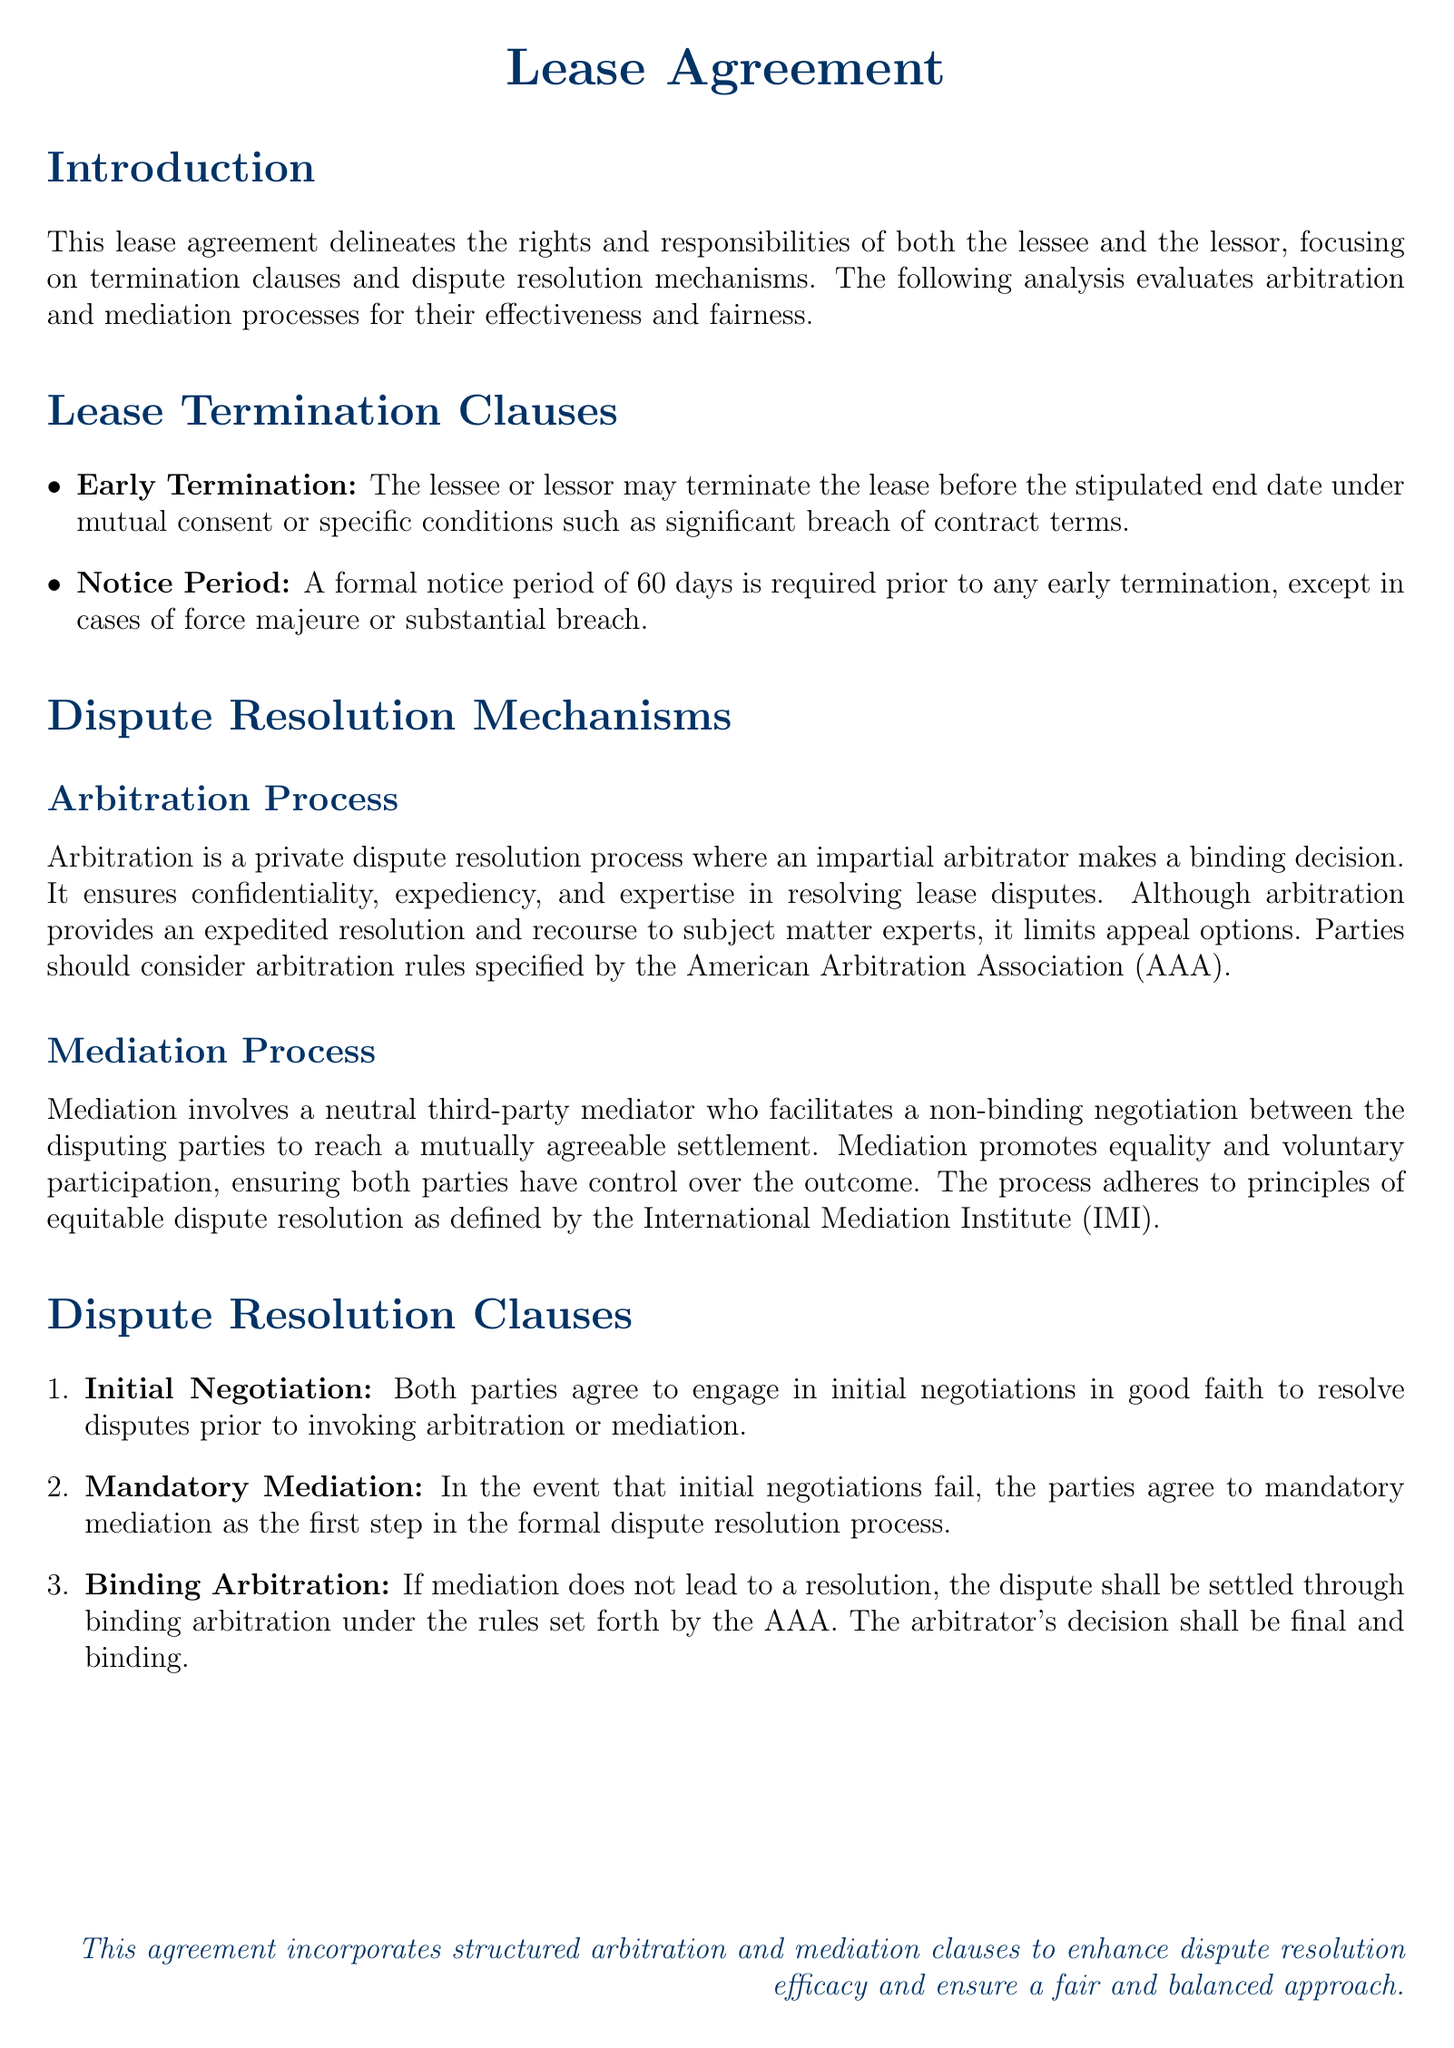What is the required notice period for early termination? The notice period for early termination is specified in the document, which is 60 days.
Answer: 60 days What is the first step in the formal dispute resolution process? According to the dispute resolution clauses, the first step is mandatory mediation after initial negotiations fail.
Answer: Mandatory mediation What is the role of the arbitrator in the arbitration process? The arbitrator's role is to make a binding decision in the arbitration process as outlined in the document.
Answer: Make a binding decision What organization’s rules govern the binding arbitration? The document specifies that the binding arbitration will be governed by the rules set forth by the American Arbitration Association.
Answer: American Arbitration Association What does mediation promote between the disputing parties? Mediation promotes equality and voluntary participation according to the characteristics detailed in the document.
Answer: Equality and voluntary participation What must both parties engage in before invoking mediation or arbitration? Both parties must engage in initial negotiations in good faith as per the dispute resolution clauses.
Answer: Initial negotiations in good faith What happens if mediation does not lead to a resolution? If mediation does not lead to a resolution, the dispute shall be settled through binding arbitration.
Answer: Binding arbitration What type of dispute resolution is described as non-binding? Mediation is described as a non-binding dispute resolution process in the document.
Answer: Non-binding 